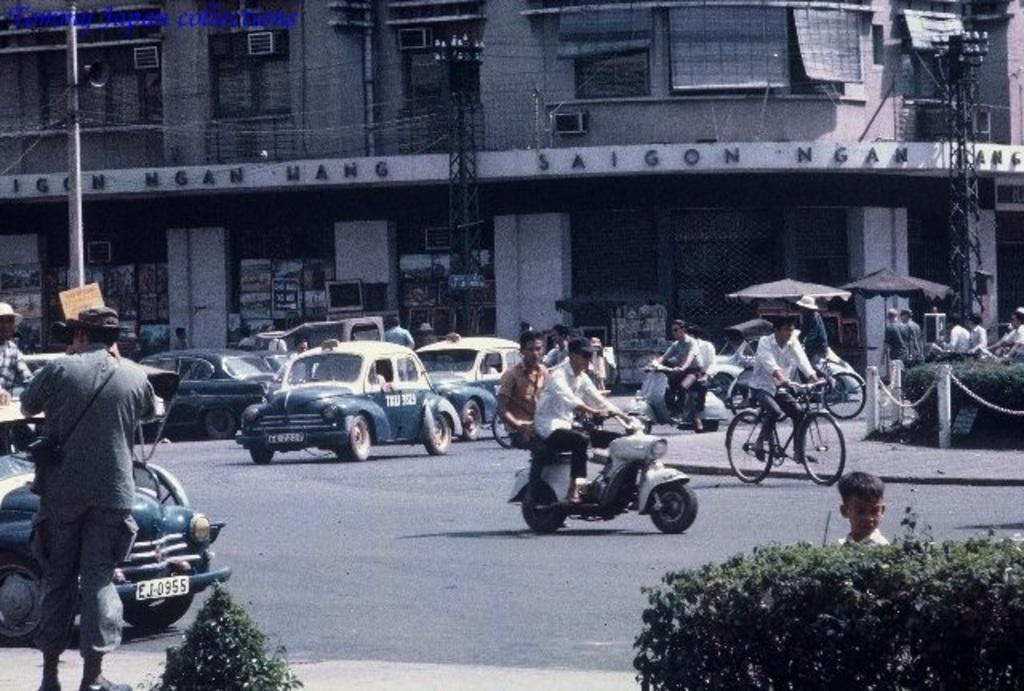Please provide a concise description of this image. This is a picture taken in a town on the road. In the foreground of the picture there pavement, on the pavement there are plants, a person and a kid. In the center of the picture there are many vehicles on the road. To the right there is a railing. In the background there is a building. On the left there is a pole. 